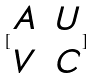<formula> <loc_0><loc_0><loc_500><loc_500>[ \begin{matrix} A & U \\ V & C \end{matrix} ]</formula> 